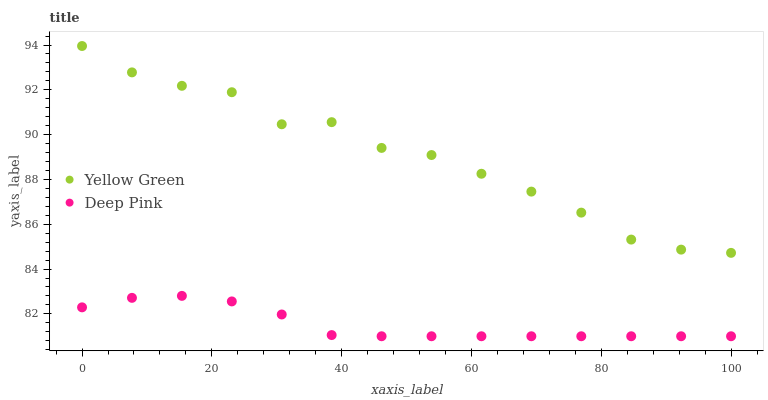Does Deep Pink have the minimum area under the curve?
Answer yes or no. Yes. Does Yellow Green have the maximum area under the curve?
Answer yes or no. Yes. Does Yellow Green have the minimum area under the curve?
Answer yes or no. No. Is Deep Pink the smoothest?
Answer yes or no. Yes. Is Yellow Green the roughest?
Answer yes or no. Yes. Is Yellow Green the smoothest?
Answer yes or no. No. Does Deep Pink have the lowest value?
Answer yes or no. Yes. Does Yellow Green have the lowest value?
Answer yes or no. No. Does Yellow Green have the highest value?
Answer yes or no. Yes. Is Deep Pink less than Yellow Green?
Answer yes or no. Yes. Is Yellow Green greater than Deep Pink?
Answer yes or no. Yes. Does Deep Pink intersect Yellow Green?
Answer yes or no. No. 